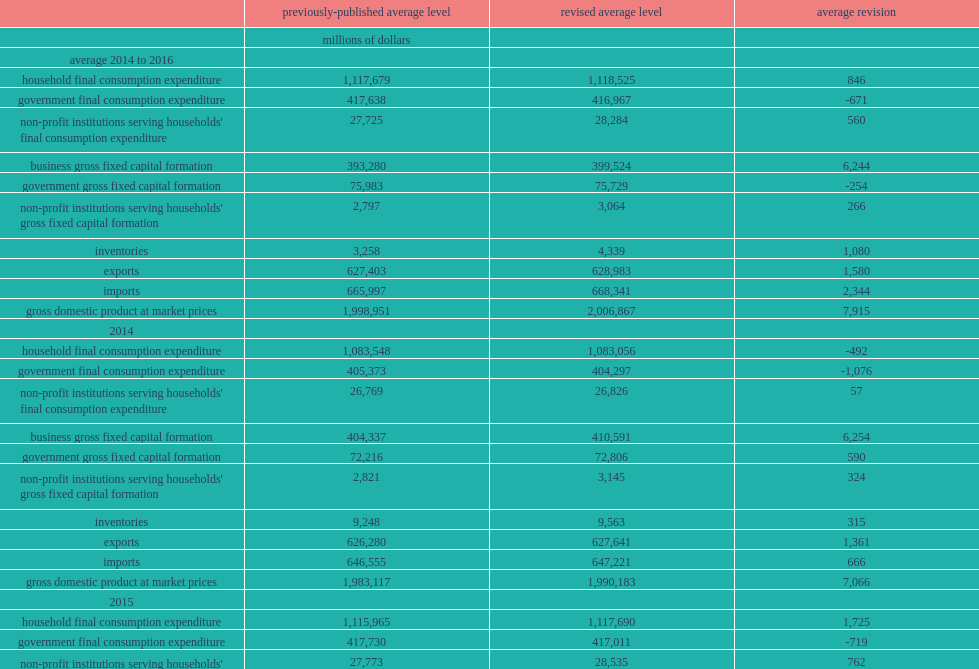What was the government final consumption expenditure revised in 2014,2015 and 2016 respectively? -1076.0 -719.0 -217.0. What was the number of business gross fixed capital formation revised in 2014,2015 and 2016 respectively? 6254.0 7531.0 4948.0. What was the number of government gross fixed capital formation revised up in 2014? 590.0. What was the number of exports of goods and services revised up in 2014? 1361.0. What was the number of imports of goods and services revised up in 2015? 3571.0. What was the number of imports of goods and services revised up in 2016? 2795.0. 